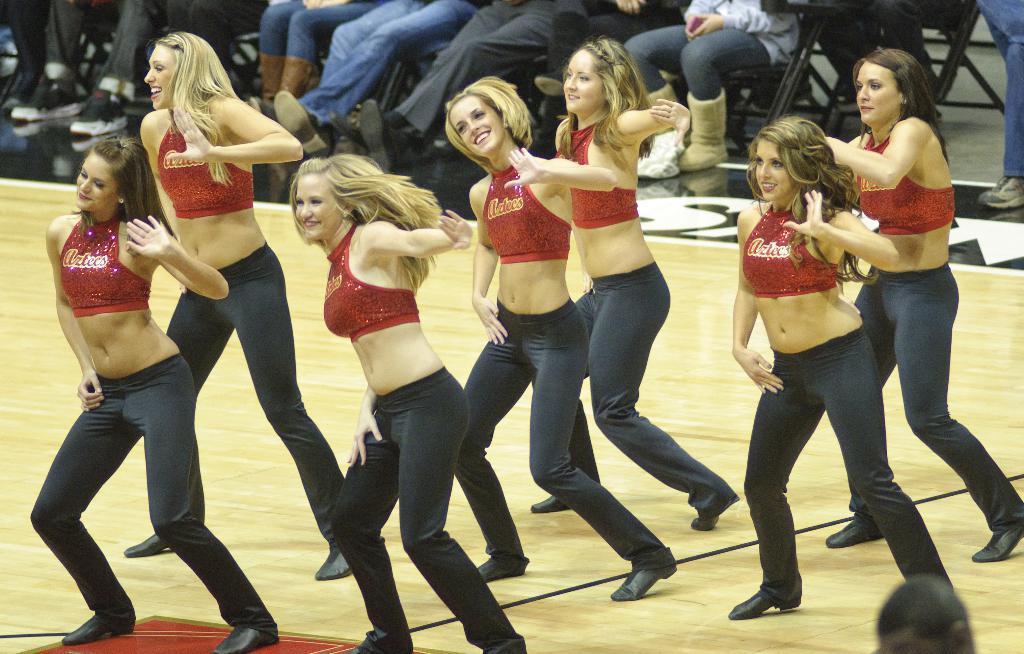Describe this image in one or two sentences. In this image there are group of women dancing, there is a wooden floor, there is a person towards the bottom of the image, there is a person holding an object, there are chairs, there are group of persons sitting towards the top of the image. 